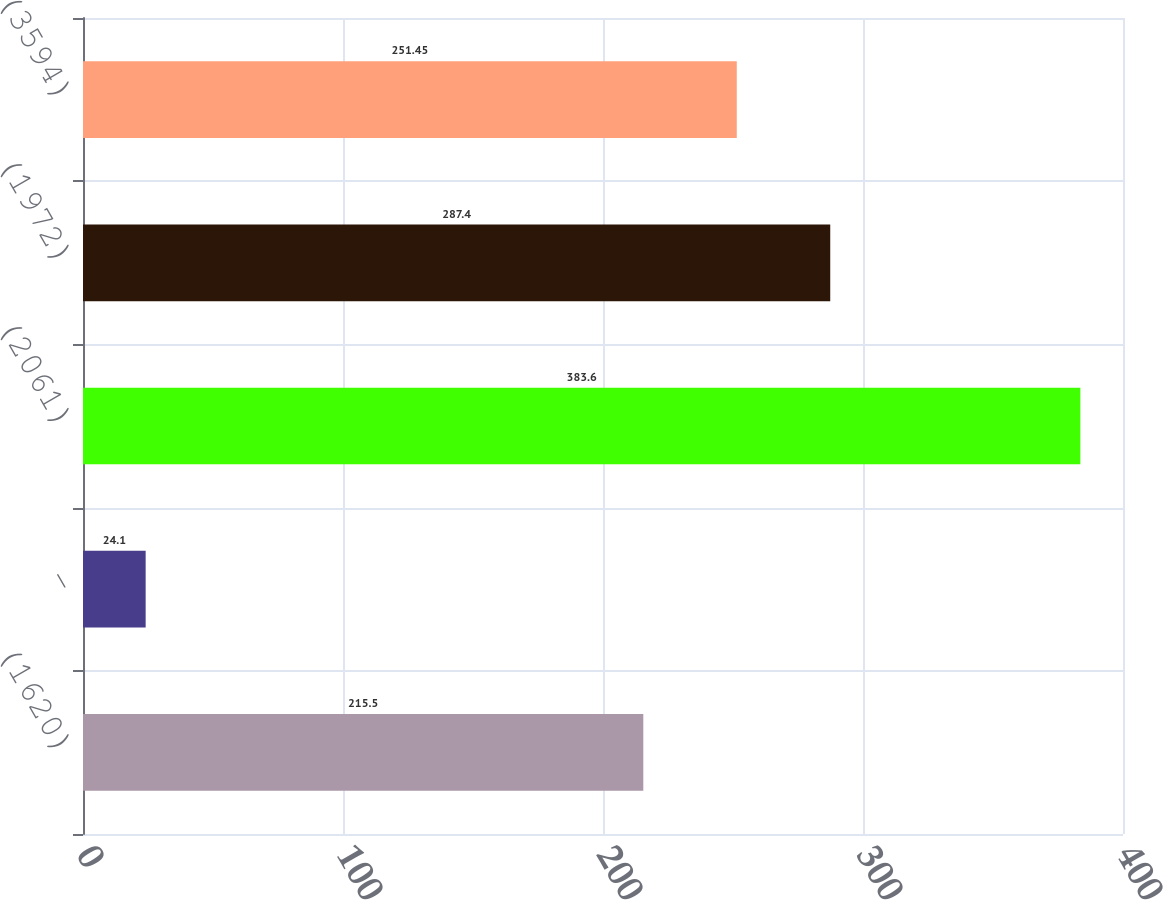Convert chart. <chart><loc_0><loc_0><loc_500><loc_500><bar_chart><fcel>(1620)<fcel>-<fcel>(2061)<fcel>(1972)<fcel>(3594)<nl><fcel>215.5<fcel>24.1<fcel>383.6<fcel>287.4<fcel>251.45<nl></chart> 